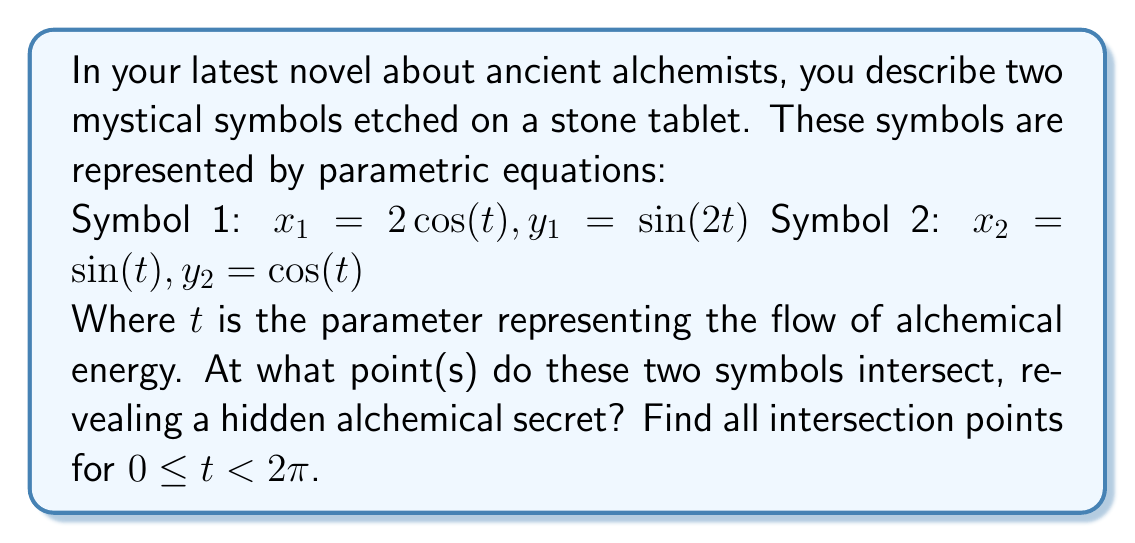What is the answer to this math problem? To find the intersection points of these two parametric curves, we need to solve the system of equations:

$$\begin{cases}
2\cos(t_1) = \sin(t_2) \\
\sin(2t_1) = \cos(t_2)
\end{cases}$$

Where $t_1$ is the parameter for Symbol 1 and $t_2$ is the parameter for Symbol 2.

Step 1: Square both equations and add them together:
$$(2\cos(t_1))^2 + (\sin(2t_1))^2 = \sin^2(t_2) + \cos^2(t_2)$$

Step 2: Simplify the left side using the identity $\sin^2(2t) = 4\sin^2(t)\cos^2(t)$:
$$4\cos^2(t_1) + 4\sin^2(t_1)\cos^2(t_1) = 1$$

Step 3: Factor out $4\cos^2(t_1)$:
$$4\cos^2(t_1)(1 + \sin^2(t_1)) = 1$$

Step 4: Use the identity $1 + \sin^2(t) = 2 - \cos^2(t)$:
$$4\cos^2(t_1)(2 - \cos^2(t_1)) = 1$$

Step 5: Expand and simplify:
$$8\cos^2(t_1) - 4\cos^4(t_1) = 1$$

Step 6: Let $u = \cos^2(t_1)$, then we have the quadratic equation:
$$4u^2 - 8u + 1 = 0$$

Step 7: Solve this quadratic equation:
$$u = \frac{8 \pm \sqrt{64 - 16}}{8} = \frac{8 \pm \sqrt{48}}{8} = \frac{8 \pm 4\sqrt{3}}{8} = 1 \pm \frac{\sqrt{3}}{2}$$

Step 8: Since $u = \cos^2(t_1)$, we only consider the positive solution:
$$\cos^2(t_1) = 1 + \frac{\sqrt{3}}{2} = \frac{2 + \sqrt{3}}{2}$$

Step 9: Solve for $t_1$:
$$t_1 = \arccos(\sqrt{\frac{2 + \sqrt{3}}{2}}) \approx 0.5536$$

Step 10: Find $t_2$ using the original equations:
$$\sin(t_2) = 2\cos(t_1) = 2\sqrt{\frac{2 + \sqrt{3}}{2}} = \sqrt{4 + 2\sqrt{3}}$$
$$t_2 = \arcsin(\sqrt{4 + 2\sqrt{3}}) \approx 1.2490$$

Step 11: Calculate the intersection point:
$$x = 2\cos(t_1) = \sin(t_2) = \sqrt{4 + 2\sqrt{3}}$$
$$y = \sin(2t_1) = \cos(t_2) = \sqrt{1 - (4 + 2\sqrt{3})} = \sqrt{-3 - 2\sqrt{3}}$$

Due to symmetry, there is another intersection point at $(-x, -y)$.
Answer: The two alchemical symbols intersect at two points:

$(\sqrt{4 + 2\sqrt{3}}, \sqrt{-3 - 2\sqrt{3}})$ and $(-\sqrt{4 + 2\sqrt{3}}, -\sqrt{-3 - 2\sqrt{3}})$

Approximately: $(2.1583, 0.8660)$ and $(-2.1583, -0.8660)$ 